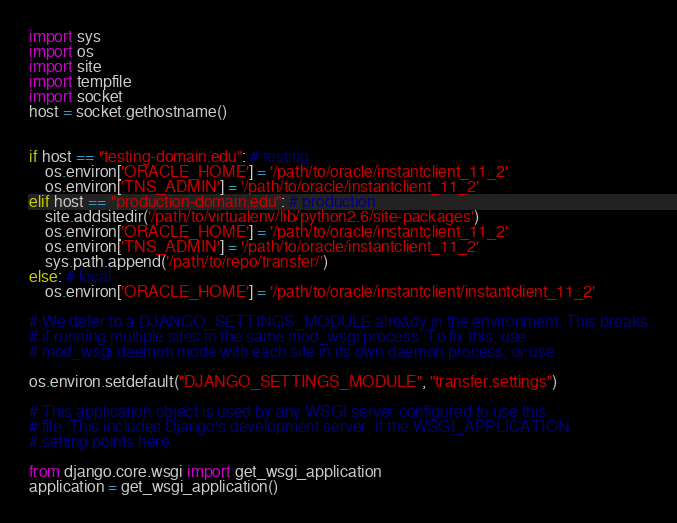Convert code to text. <code><loc_0><loc_0><loc_500><loc_500><_Python_>import sys
import os 
import site
import tempfile
import socket
host = socket.gethostname()


if host == "testing-domain.edu": # testing 
    os.environ['ORACLE_HOME'] = '/path/to/oracle/instantclient_11_2'
    os.environ['TNS_ADMIN'] = '/path/to/oracle/instantclient_11_2'
elif host == "production-domain.edu": # production
    site.addsitedir('/path/to/virtualenv/lib/python2.6/site-packages')
    os.environ['ORACLE_HOME'] = '/path/to/oracle/instantclient_11_2'
    os.environ['TNS_ADMIN'] = '/path/to/oracle/instantclient_11_2'
    sys.path.append('/path/to/repo/transfer/')
else: # local
    os.environ['ORACLE_HOME'] = '/path/to/oracle/instantclient/instantclient_11_2'

# We defer to a DJANGO_SETTINGS_MODULE already in the environment. This breaks
# if running multiple sites in the same mod_wsgi process. To fix this, use
# mod_wsgi daemon mode with each site in its own daemon process, or use

os.environ.setdefault("DJANGO_SETTINGS_MODULE", "transfer.settings")

# This application object is used by any WSGI server configured to use this
# file. This includes Django's development server, if the WSGI_APPLICATION
# setting points here.

from django.core.wsgi import get_wsgi_application
application = get_wsgi_application()


</code> 